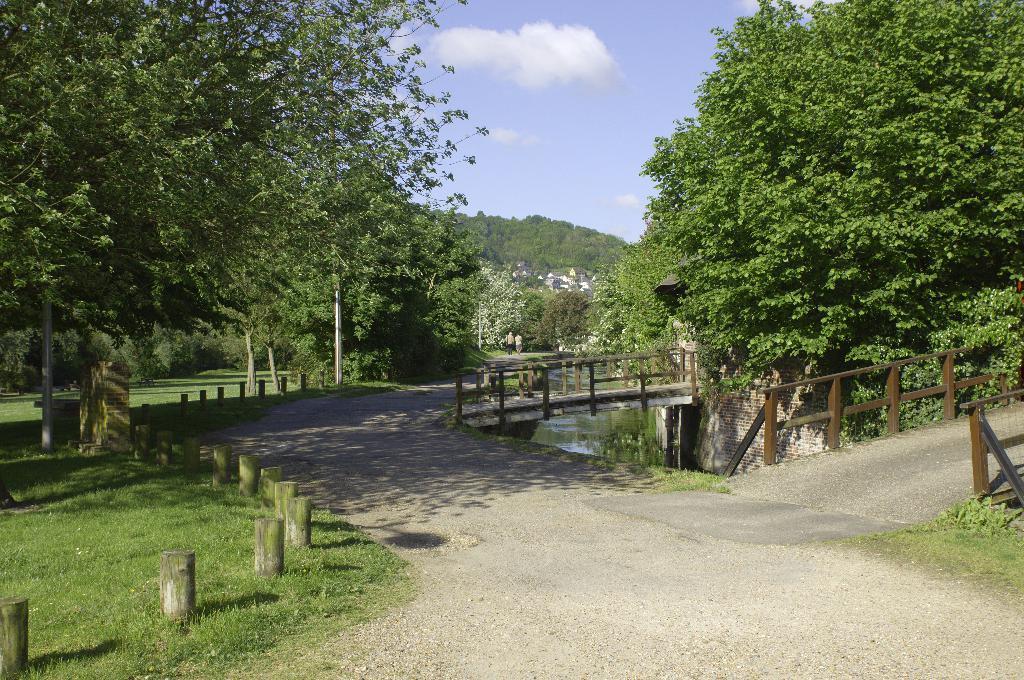Could you give a brief overview of what you see in this image? There is a road. On the left side there is grass lawn. Also there are poles and trees. On the right side there are bridges with railings. There is a river. Also there are trees. In the background there are trees and sky. 